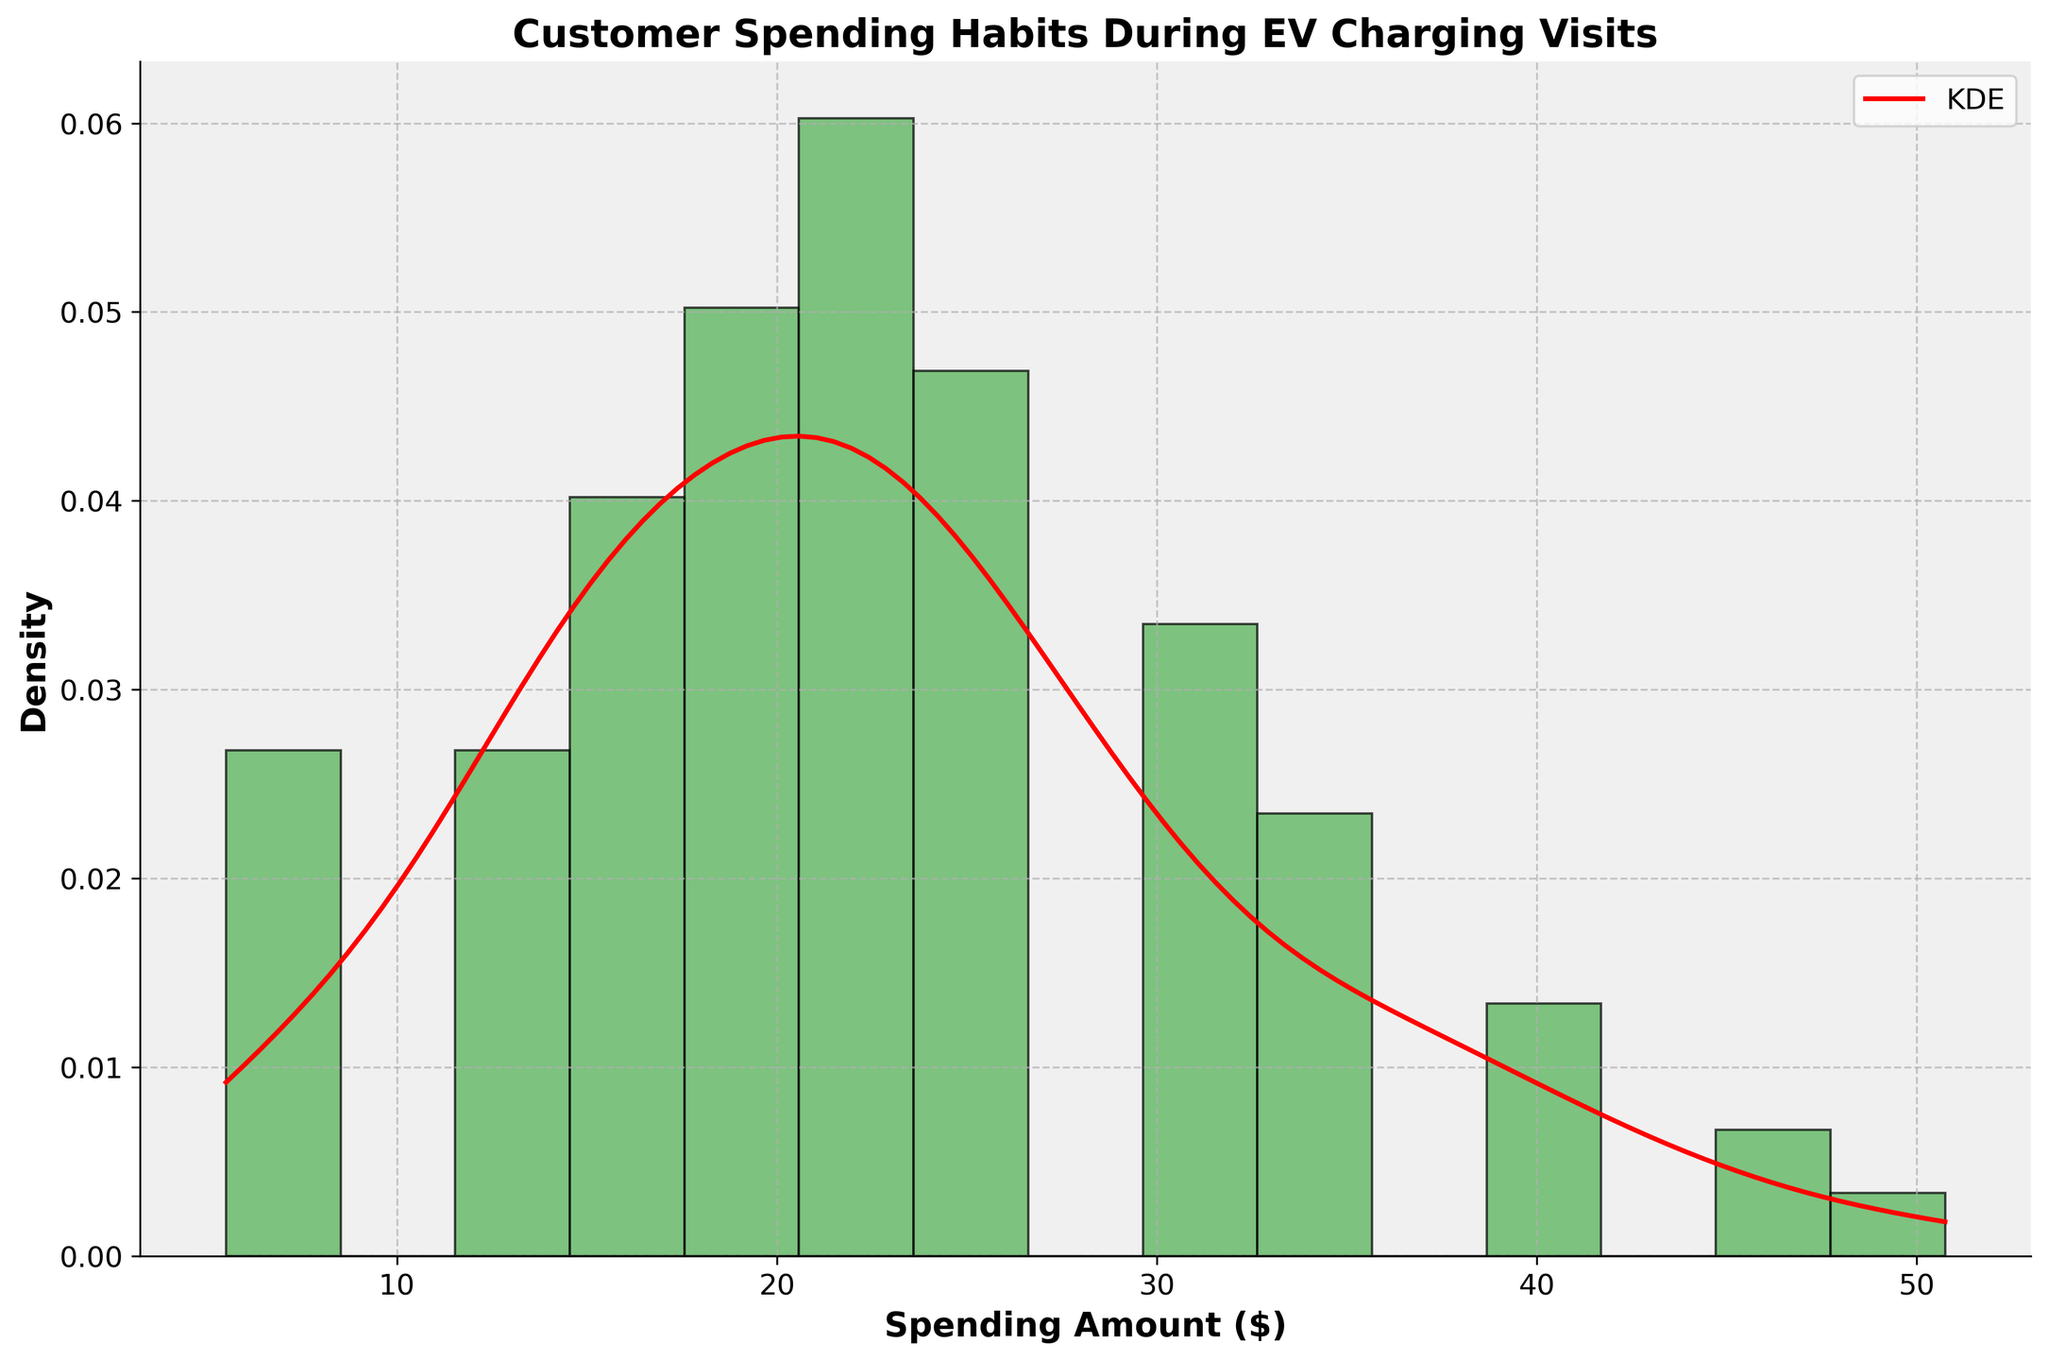What is the title of the figure? The title of the figure is located at the top and usually describes the overall purpose or the main subject of the figure. In this case, it states what the figure is about, which is customer spending habits during EV charging visits.
Answer: Customer Spending Habits During EV Charging Visits What are the labels of the x-axis and y-axis? The x-axis label is at the bottom of the figure and describes what is being measured along the horizontal axis. The y-axis label is on the left side and describes what is being measured along the vertical axis. In this figure, the x-axis labels 'Spending Amount ($)' and the y-axis labels 'Density'.
Answer: Spending Amount ($); Density How many bins are in the histogram? In a histogram, bins are the intervals that represent the frequency of data points. By visually counting the columns in the histogram, one can determine the number of bins.
Answer: 15 Where does the maximum frequency occur in the histogram? The maximum frequency is where the tallest bar in the histogram is located. By visually inspecting the histogram, we can identify that the tallest bar corresponds to the spending amount between $18.50 and $22.00.
Answer: Between $18.50 and $22.00 What color is the histogram bars and the KDE curve? The histogram bars are colored, usually filled with one solid color, and the KDE curve is represented by another distinct color. In this figure, the bars are green, and the KDE curve is red.
Answer: Green; Red What is the spending amount at the peak of the density curve (KDE)? The peak of the KDE curve is the highest point on the red line, representing the highest density. By tracing this point to the x-axis, we can find the spending amount at this peak value.
Answer: About $22.00 How does the density change from $5.50 to $50.75? Observe the behavior of the red KDE curve from the lowest spending amount ($5.50) to the highest ($50.75). Note the slope changes, peaks, and valleys.
Answer: The density increases initially, reaches a peak around $22.00, then declines towards $50.75 Which spending amount ranges show a declining density from their peak, according to the KDE curve? Identify regions along the red KDE curve where the density decreases after reaching a maximum point. This is usually the downward slope of the curve beyond the peak.
Answer: Beyond $22.00, the density declines What can you infer about customer spending habits based on the histogram and KDE curve? Analyze the overall distribution shown by the histogram and KDE curve, noting where most spending occurs and how frequently different spending amounts take place. The pattern suggests a concentration around certain values with fewer extreme values.
Answer: Most customers spend around $22.00, with fewer spending much less or much more Why might it be useful to consider both the histogram and KDE curve when analyzing customer spending habits? The histogram shows the frequency distribution in discrete intervals while the KDE curve provides a continuous estimate of the probability density function. Together, they give a more complete picture of the data distribution.
Answer: Histogram shows frequency, KDE shows probability density 